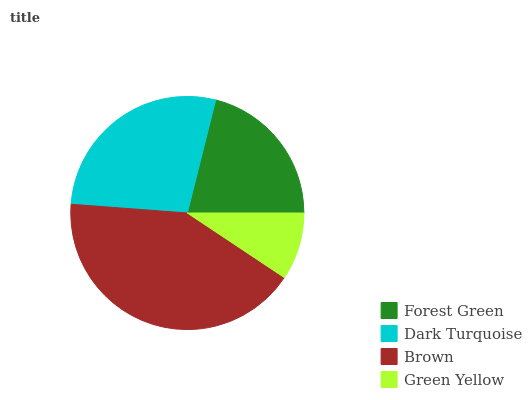Is Green Yellow the minimum?
Answer yes or no. Yes. Is Brown the maximum?
Answer yes or no. Yes. Is Dark Turquoise the minimum?
Answer yes or no. No. Is Dark Turquoise the maximum?
Answer yes or no. No. Is Dark Turquoise greater than Forest Green?
Answer yes or no. Yes. Is Forest Green less than Dark Turquoise?
Answer yes or no. Yes. Is Forest Green greater than Dark Turquoise?
Answer yes or no. No. Is Dark Turquoise less than Forest Green?
Answer yes or no. No. Is Dark Turquoise the high median?
Answer yes or no. Yes. Is Forest Green the low median?
Answer yes or no. Yes. Is Brown the high median?
Answer yes or no. No. Is Brown the low median?
Answer yes or no. No. 